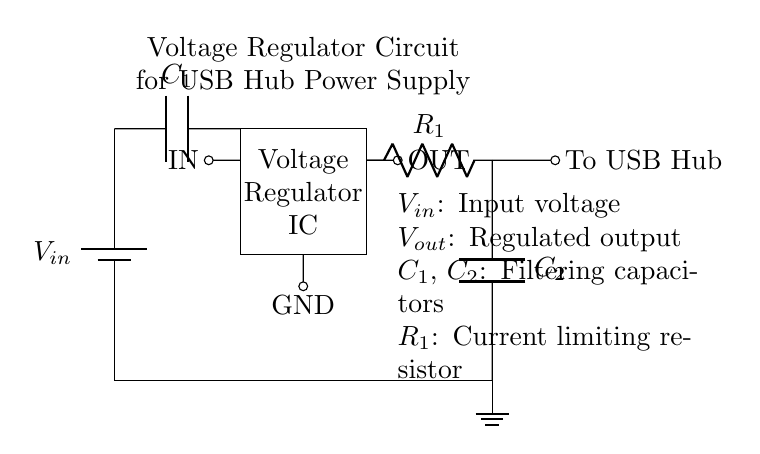What is the purpose of C1 in this circuit? Capacitor C1 is used for filtering, which helps to smooth out the voltage coming from the input source. This ensures a stable voltage supply for the voltage regulator IC.
Answer: Filtering What does the resistor R1 do? Resistor R1 is a current limiting resistor, which regulates the amount of current flowing through the circuit to protect components from excessive current that could damage them.
Answer: Current limiting How many capacitors are in the circuit? The circuit contains two capacitors, C1 and C2, which serve different functions in filtering and stability.
Answer: Two What type of circuit is this? This is a voltage regulator circuit, designed to provide a stable output voltage for devices like a USB hub.
Answer: Voltage regulator What is the output connection labeled as? The output connection is labeled as "OUT," indicating where the regulated voltage is supplied to the USB hub.
Answer: OUT What is the ground reference point in this diagram? The ground reference point is represented by the ground symbol at the bottom of the circuit, providing a common return path for current.
Answer: Ground 